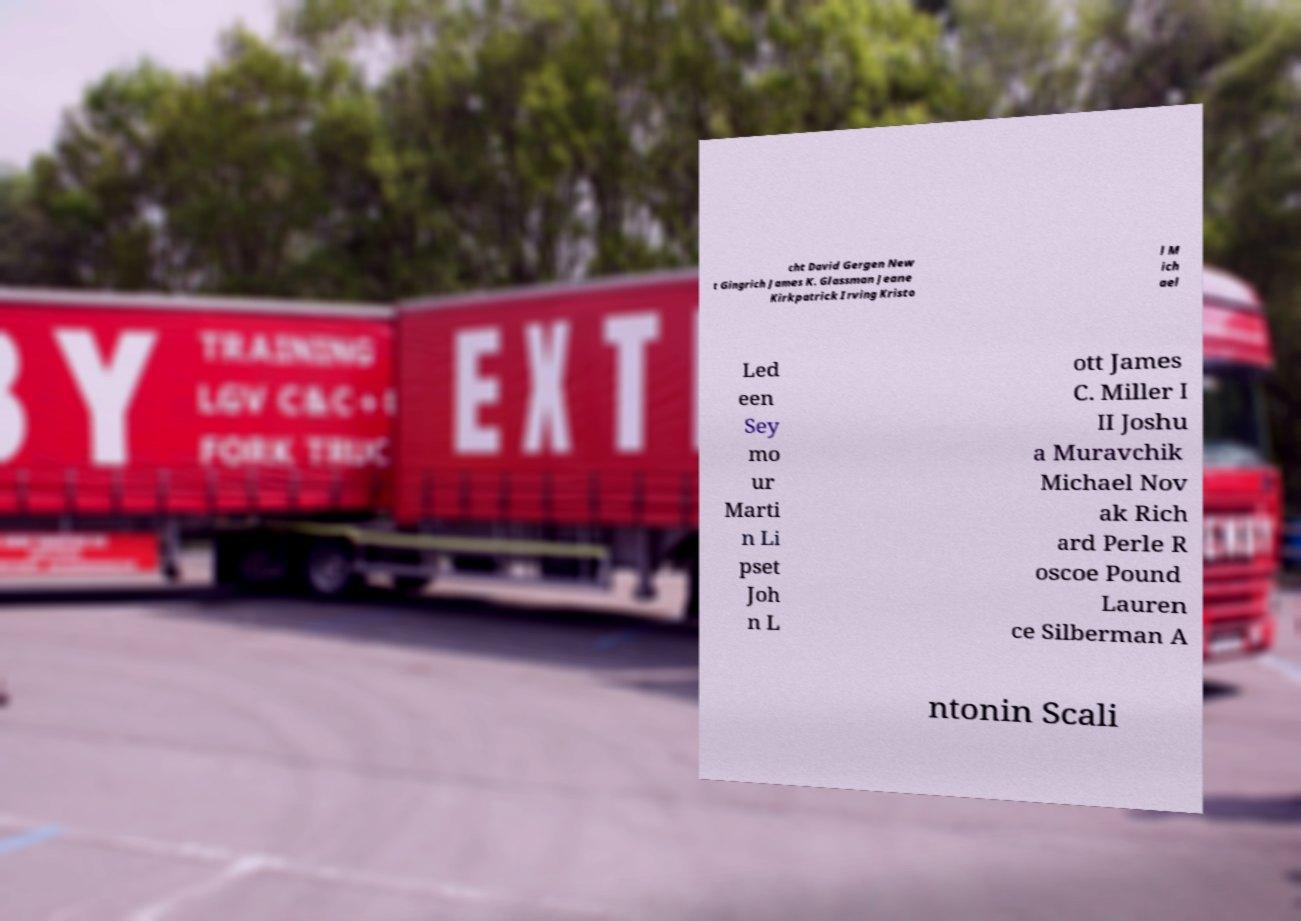Please identify and transcribe the text found in this image. cht David Gergen New t Gingrich James K. Glassman Jeane Kirkpatrick Irving Kristo l M ich ael Led een Sey mo ur Marti n Li pset Joh n L ott James C. Miller I II Joshu a Muravchik Michael Nov ak Rich ard Perle R oscoe Pound Lauren ce Silberman A ntonin Scali 